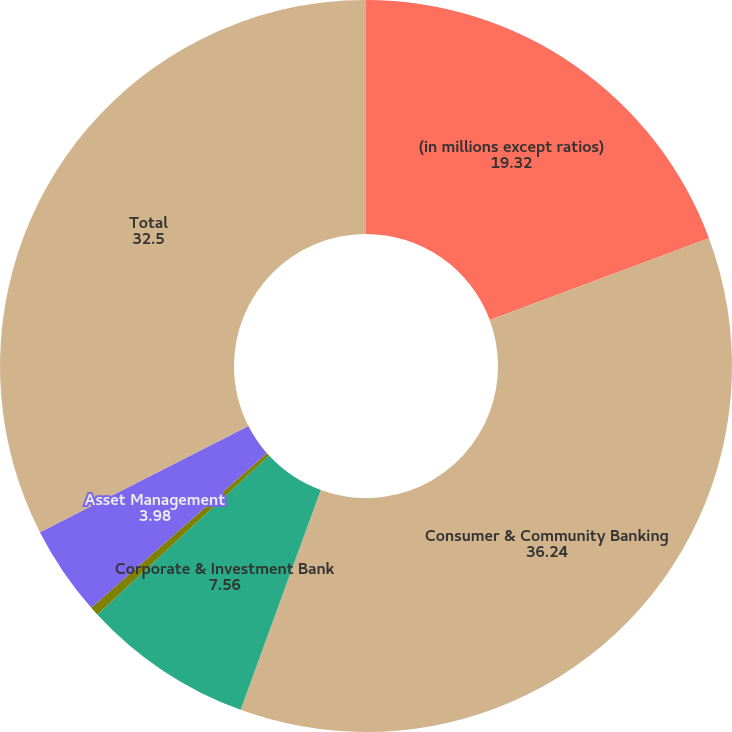<chart> <loc_0><loc_0><loc_500><loc_500><pie_chart><fcel>(in millions except ratios)<fcel>Consumer & Community Banking<fcel>Corporate & Investment Bank<fcel>Commercial Banking<fcel>Asset Management<fcel>Total<nl><fcel>19.32%<fcel>36.24%<fcel>7.56%<fcel>0.39%<fcel>3.98%<fcel>32.5%<nl></chart> 